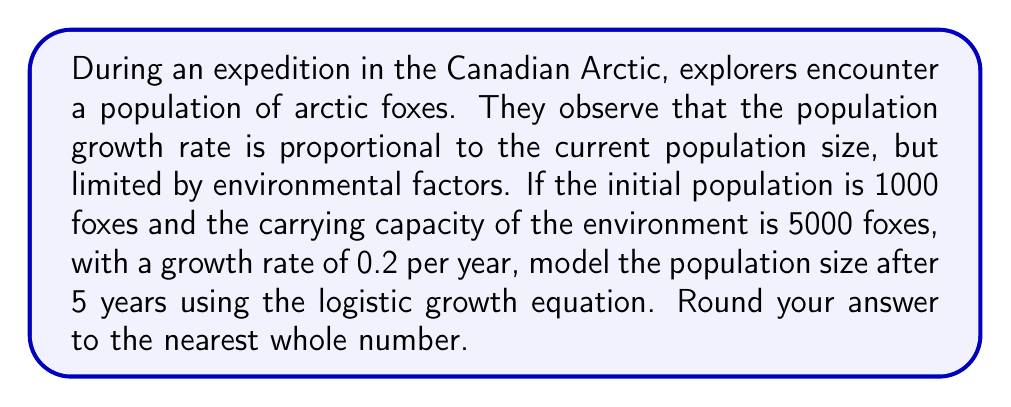Can you answer this question? To model the population dynamics of the arctic foxes, we'll use the logistic growth equation:

$$\frac{dP}{dt} = rP(1 - \frac{P}{K})$$

Where:
$P$ is the population size
$t$ is time
$r$ is the growth rate
$K$ is the carrying capacity

Given:
Initial population, $P_0 = 1000$
Carrying capacity, $K = 5000$
Growth rate, $r = 0.2$ per year
Time, $t = 5$ years

The solution to the logistic growth equation is:

$$P(t) = \frac{KP_0e^{rt}}{K + P_0(e^{rt} - 1)}$$

Let's solve this step-by-step:

1) Substitute the given values into the equation:

   $$P(5) = \frac{5000 \cdot 1000 \cdot e^{0.2 \cdot 5}}{5000 + 1000(e^{0.2 \cdot 5} - 1)}$$

2) Calculate $e^{0.2 \cdot 5}$:
   
   $e^{0.2 \cdot 5} = e^1 \approx 2.71828$

3) Substitute this value:

   $$P(5) = \frac{5000000 \cdot 2.71828}{5000 + 1000(2.71828 - 1)}$$

4) Simplify:

   $$P(5) = \frac{13591400}{5000 + 1718.28} = \frac{13591400}{6718.28}$$

5) Calculate the final result:

   $$P(5) \approx 2022.98$$

6) Round to the nearest whole number:

   $$P(5) \approx 2023$$
Answer: 2023 foxes 